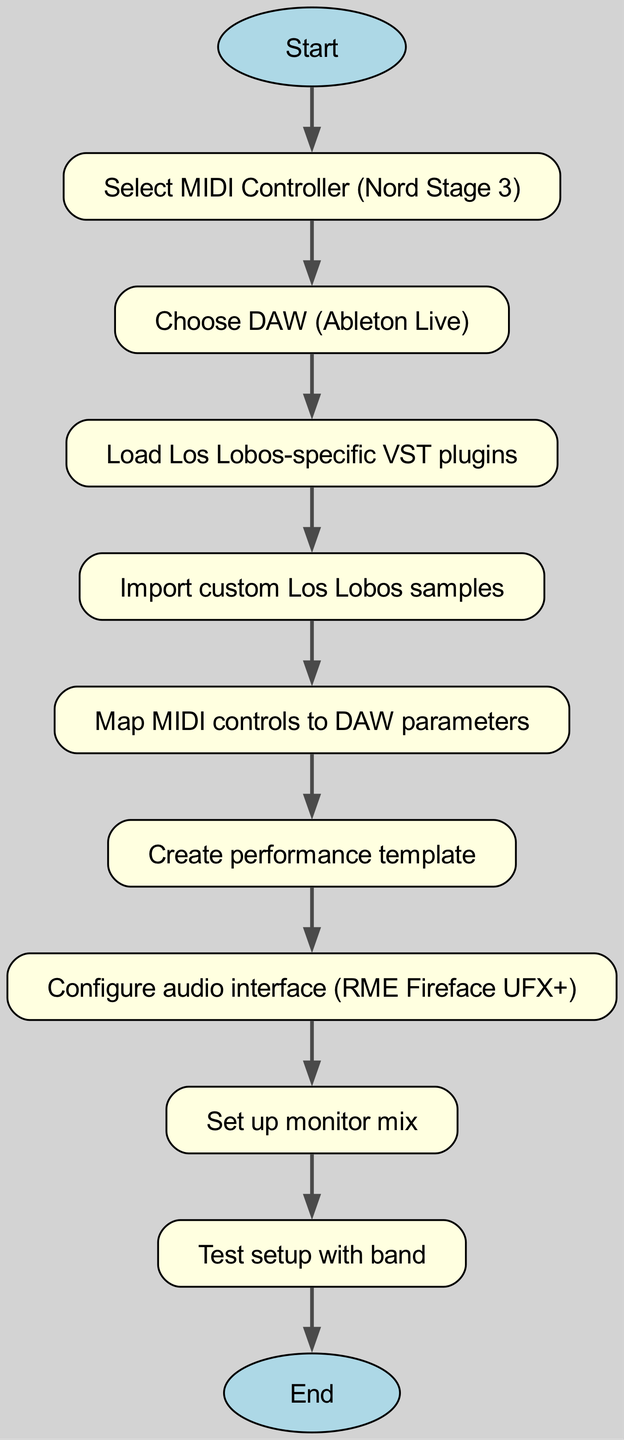What is the first step in the flowchart? The first step is indicated by the "Start" node, which leads to the selection of a MIDI Controller.
Answer: Start How many nodes are in the flowchart? The flowchart contains a total of 10 nodes, including the start and end points.
Answer: 10 Which MIDI controller is selected? The flowchart specifically names the Nord Stage 3 as the MIDI controller to be selected.
Answer: Nord Stage 3 What comes after loading the VST plugins? After loading the VST plugins, the next step in the flowchart is to import custom Los Lobos samples.
Answer: Import custom Los Lobos samples Explain the relationship between DAW and VST plugins. The flowchart shows a sequential connection where, after choosing the DAW (Ableton Live), the next step is to load the Los Lobos-specific VST plugins, indicating plugins are used within the chosen DAW.
Answer: Load Los Lobos-specific VST plugins What is the last step before ending the flowchart? The last step before reaching the end is testing the setup with the band, indicating it's the final verification stage.
Answer: Test setup with band How many edges are there in the diagram? The flowchart comprises 9 edges, representing connections between the steps from the start to the end node.
Answer: 9 What is the purpose of the audio interface in the flowchart? The audio interface, represented as RME Fireface UFX+, is configured after creating the performance template, which implies it's essential for audio output and input management during performances.
Answer: Configure audio interface (RME Fireface UFX+) 